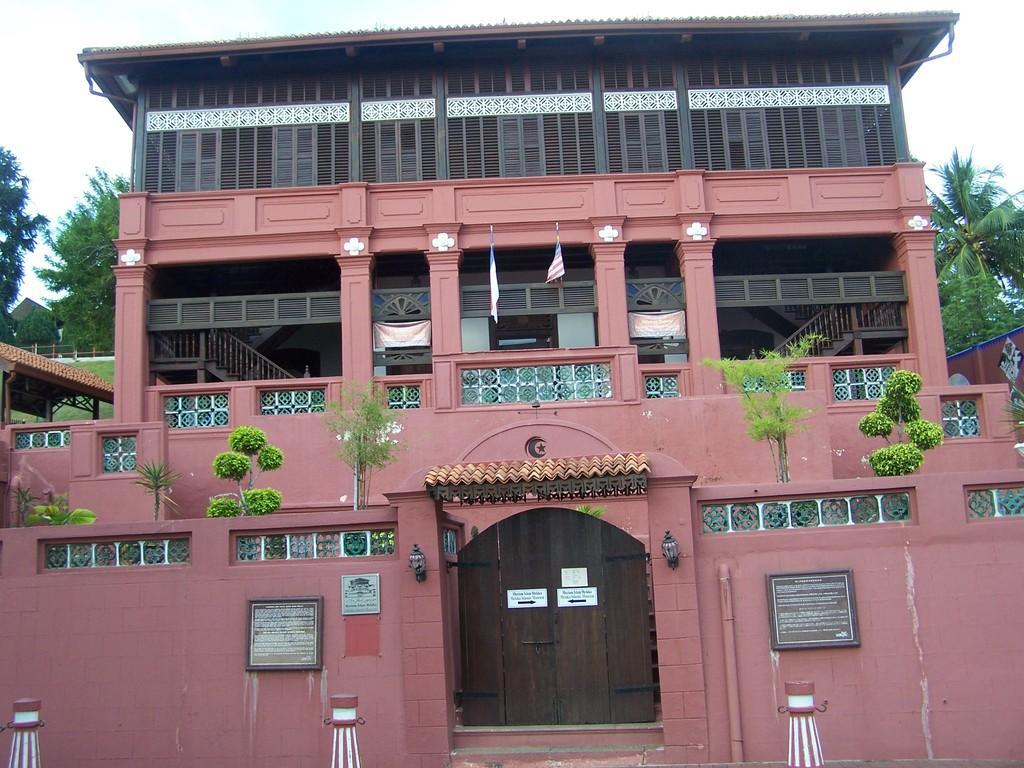Describe this image in one or two sentences. In this image I can see a building on which there are some plants on it. Here I can see boards on the wall. In the background I can see trees and the sky. Here I can see a door. 